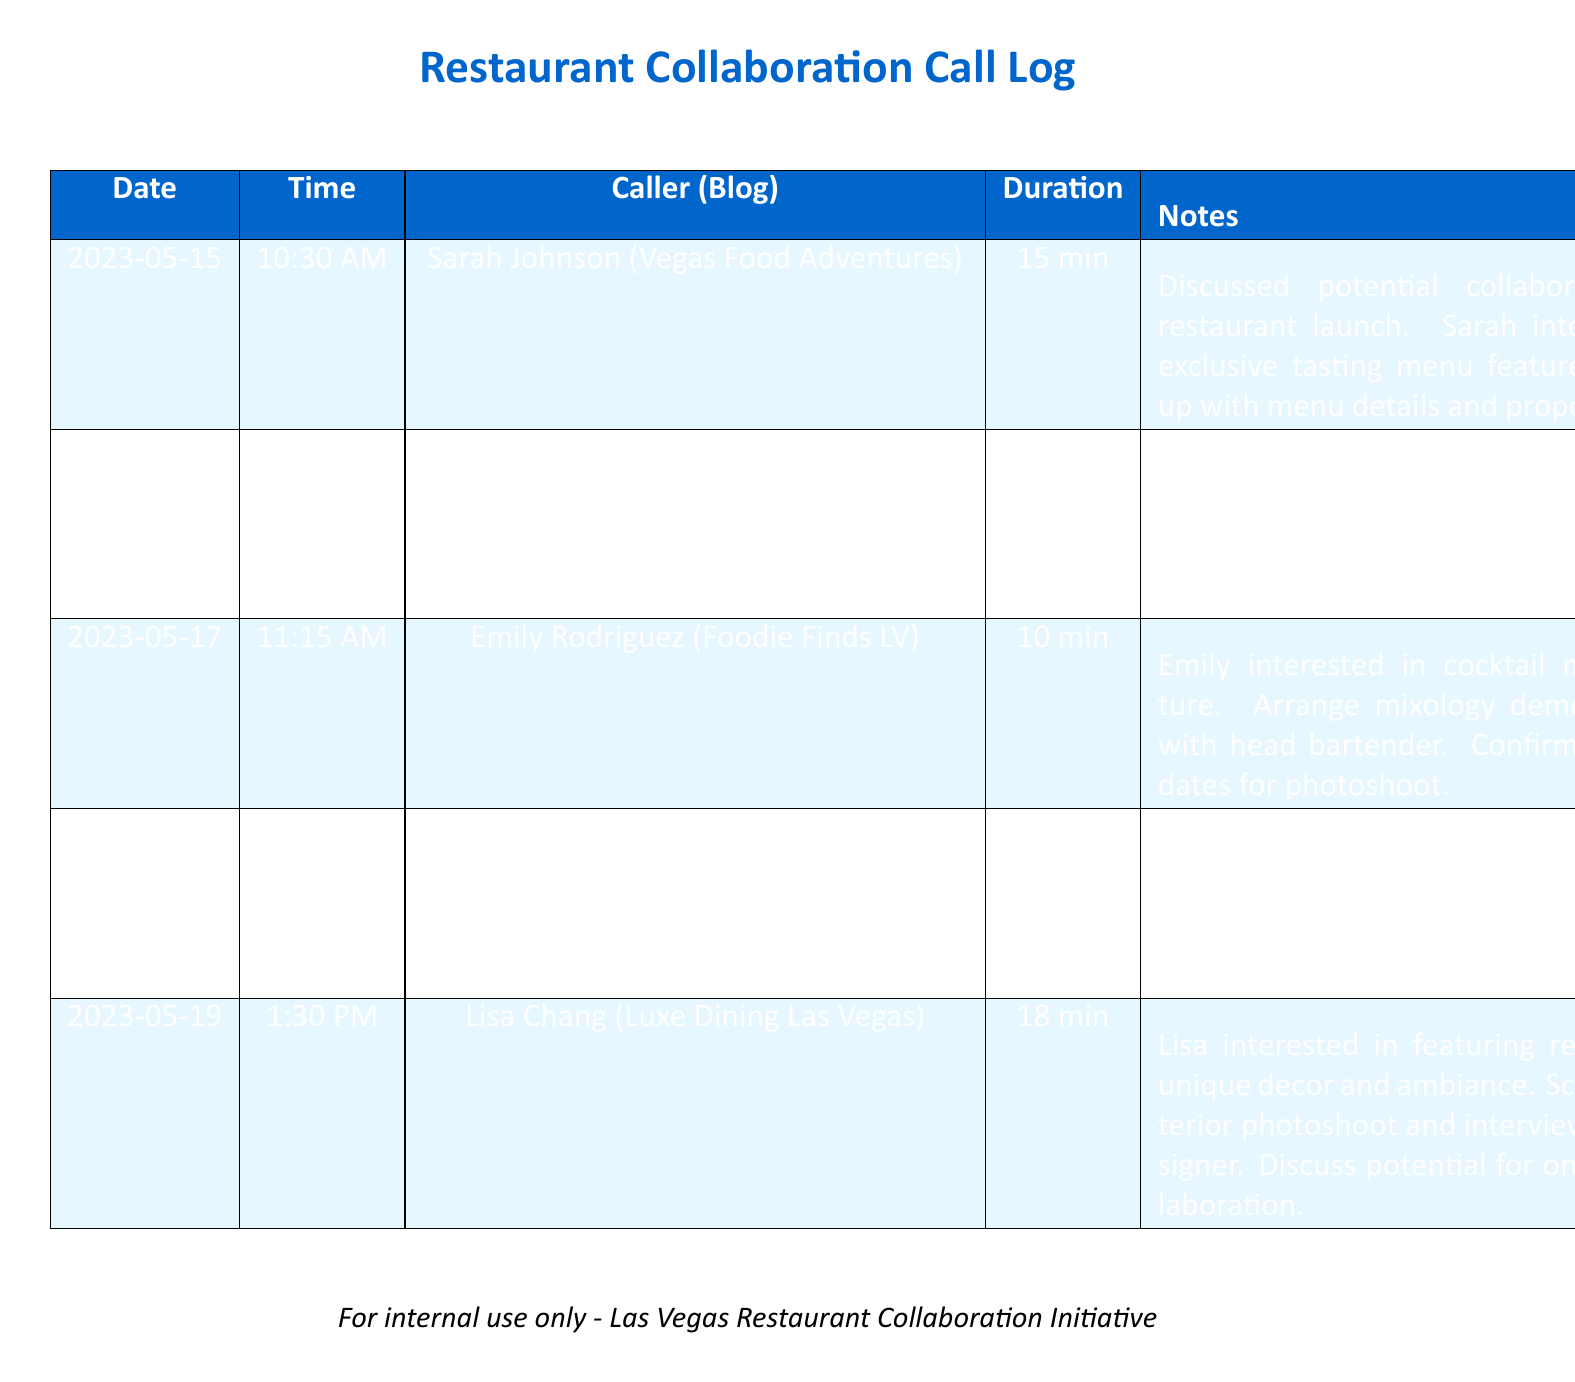what is the date of the first call? The first call in the log is dated May 15, 2023.
Answer: May 15, 2023 who called on May 18, 2023? According to the log, David Thompson from Vegas Veggie Voyages called on this date.
Answer: David Thompson how long was the call with Mike Chen? The record shows that the call with Mike Chen lasted 20 minutes.
Answer: 20 min what was Emily Rodriguez interested in? The notes indicate that Emily was interested in featuring the cocktail menu.
Answer: cocktail menu feature how many bloggers were contacted in total? The log contains records of five distinct phone calls to bloggers.
Answer: 5 which collaboration involved a vegetarian theme? The collaboration with David Thompson focused on vegetarian options.
Answer: David Thompson what follow-up action is required after the call with Sarah Johnson? The follow-up action is to provide menu details and propose a date for the tasting menu feature.
Answer: Menu details and proposed date what was discussed in the call with Lisa Chang? The call with Lisa Chang involved the restaurant's unique decor and ambiance.
Answer: unique decor and ambiance when is the scheduled kitchen tour with Mike Chen? The kitchen tour with Mike Chen is scheduled for next week.
Answer: next week 